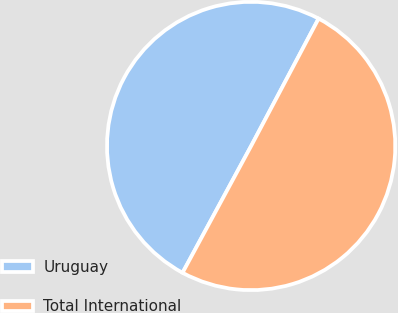Convert chart. <chart><loc_0><loc_0><loc_500><loc_500><pie_chart><fcel>Uruguay<fcel>Total International<nl><fcel>49.86%<fcel>50.14%<nl></chart> 